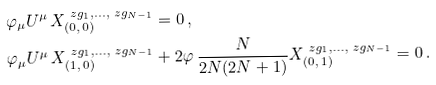Convert formula to latex. <formula><loc_0><loc_0><loc_500><loc_500>& \varphi _ { \mu } U ^ { \mu } \, X _ { ( 0 , \, 0 ) } ^ { \ z g _ { 1 } , \dots , \ z g _ { N - 1 } } = 0 \, , \\ & \varphi _ { \mu } U ^ { \mu } \, X _ { ( 1 , \, 0 ) } ^ { \ z g _ { 1 } , \dots , \ z g _ { N - 1 } } + 2 \varphi \, \frac { N } { 2 N ( 2 N + 1 ) } X _ { ( 0 , \, 1 ) } ^ { \ z g _ { 1 } , \dots , \ z g _ { N - 1 } } = 0 \, .</formula> 